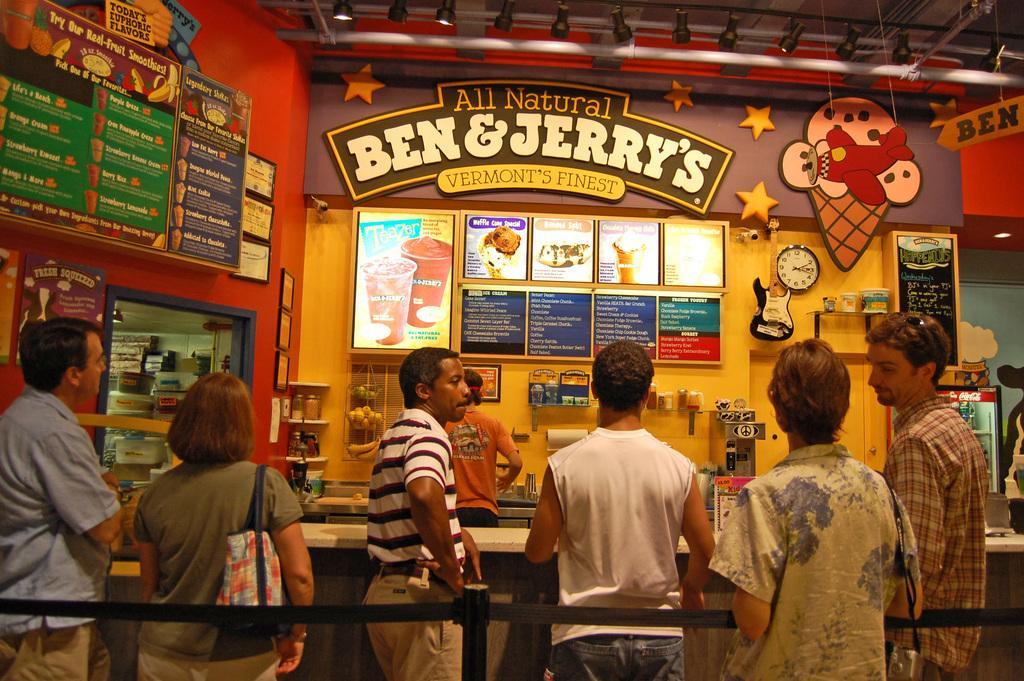Please provide a concise description of this image. In this image there are a few people standing. In front of them there is a table. Behind the table there is another person standing. In the background there is a wall. There are boards and picture frames on the wall. To the right there are boxes, a clock and a guitar hanging on the wall. In the center there are shelves. There are fruits and jars in the shelves. At the top there is a ceiling. There are lights hanging to the ceiling. To the left there is a glass windows. On the other side of the window there are boxes. 